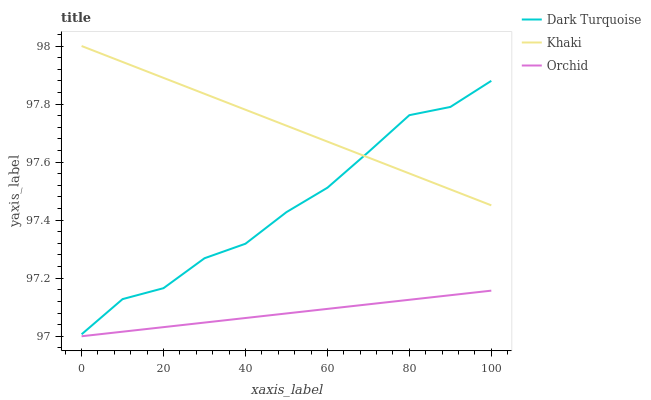Does Orchid have the minimum area under the curve?
Answer yes or no. Yes. Does Khaki have the maximum area under the curve?
Answer yes or no. Yes. Does Khaki have the minimum area under the curve?
Answer yes or no. No. Does Orchid have the maximum area under the curve?
Answer yes or no. No. Is Orchid the smoothest?
Answer yes or no. Yes. Is Dark Turquoise the roughest?
Answer yes or no. Yes. Is Khaki the smoothest?
Answer yes or no. No. Is Khaki the roughest?
Answer yes or no. No. Does Khaki have the lowest value?
Answer yes or no. No. Does Khaki have the highest value?
Answer yes or no. Yes. Does Orchid have the highest value?
Answer yes or no. No. Is Orchid less than Khaki?
Answer yes or no. Yes. Is Dark Turquoise greater than Orchid?
Answer yes or no. Yes. Does Dark Turquoise intersect Khaki?
Answer yes or no. Yes. Is Dark Turquoise less than Khaki?
Answer yes or no. No. Is Dark Turquoise greater than Khaki?
Answer yes or no. No. Does Orchid intersect Khaki?
Answer yes or no. No. 